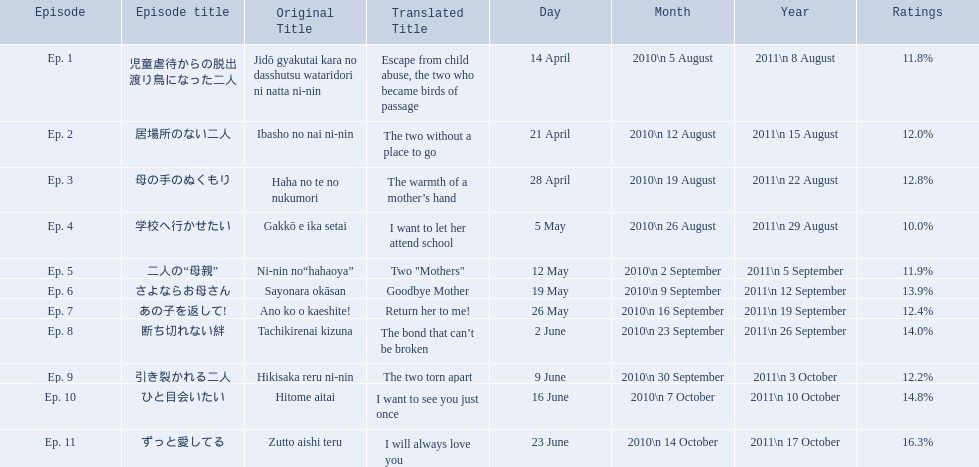Which episode had the highest ratings? Ep. 11. Which episode was named haha no te no nukumori? Ep. 3. Besides episode 10 which episode had a 14% rating? Ep. 8. 